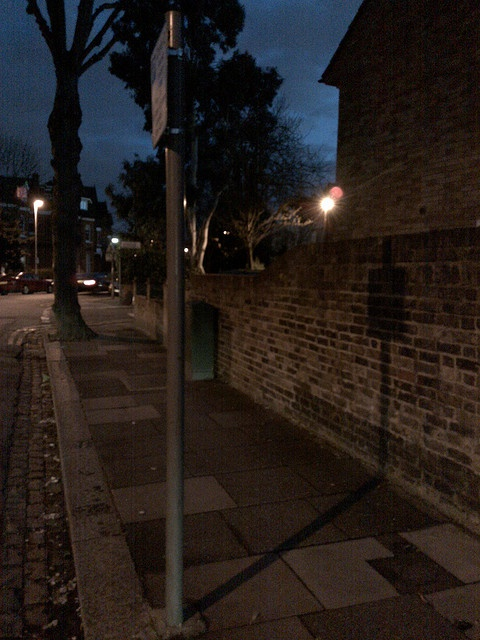Describe the objects in this image and their specific colors. I can see car in blue, black, maroon, and gray tones, car in blue, black, maroon, white, and gray tones, and car in blue, black, gray, and darkgray tones in this image. 